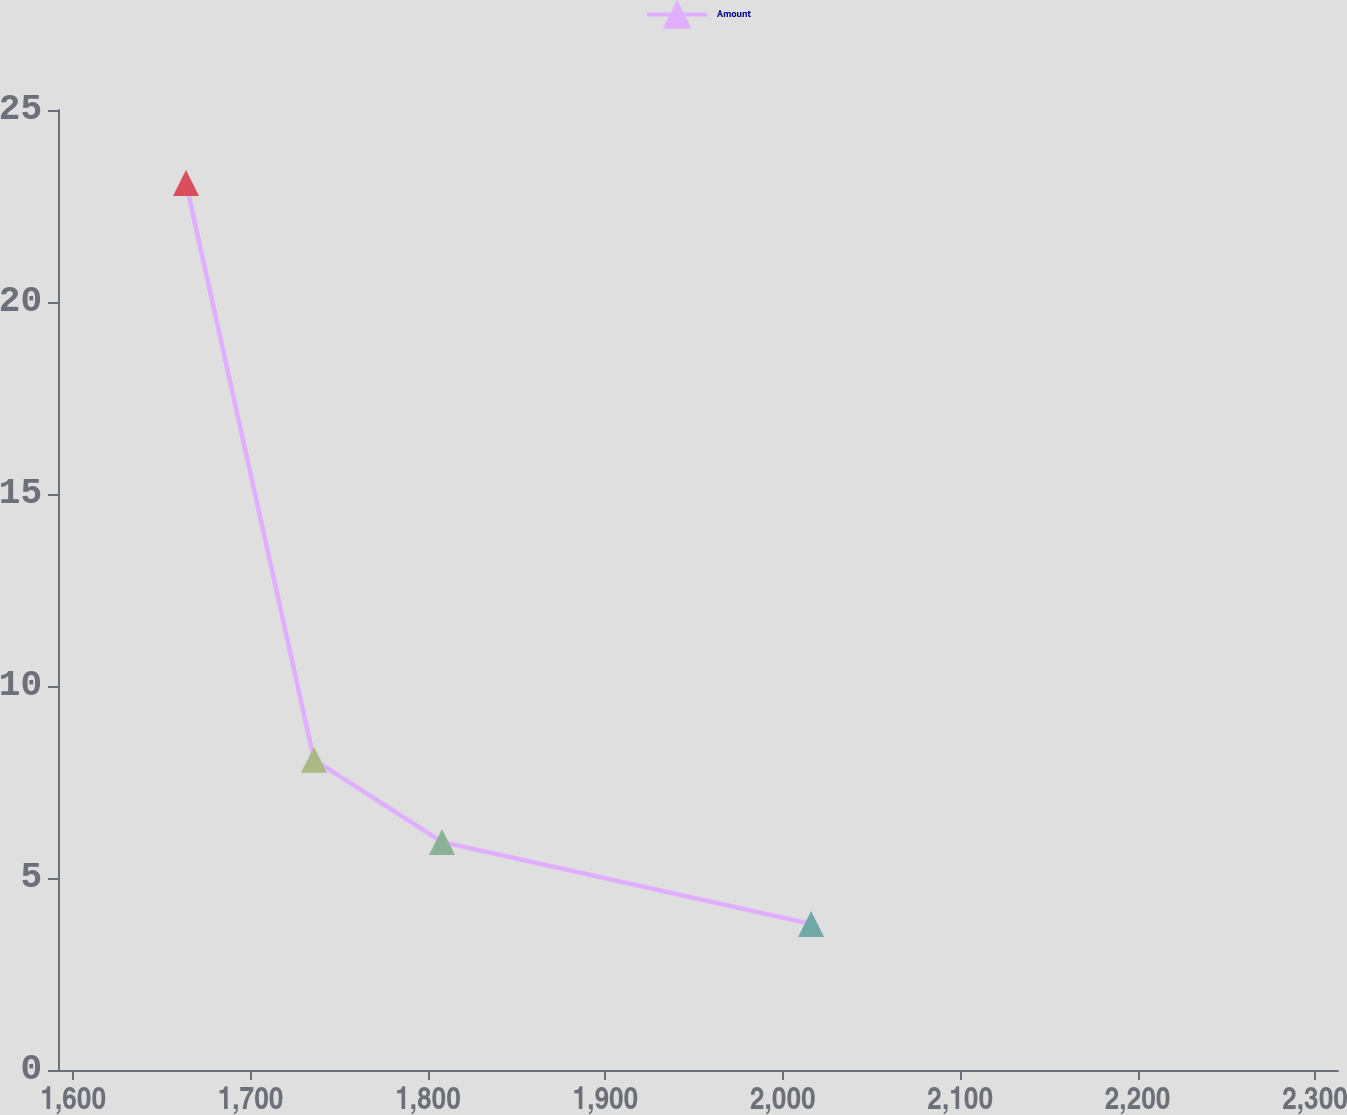Convert chart to OTSL. <chart><loc_0><loc_0><loc_500><loc_500><line_chart><ecel><fcel>Amount<nl><fcel>1663.61<fcel>23.1<nl><fcel>1735.76<fcel>8.08<nl><fcel>1807.91<fcel>5.94<nl><fcel>2015.97<fcel>3.8<nl><fcel>2385.11<fcel>1.66<nl></chart> 